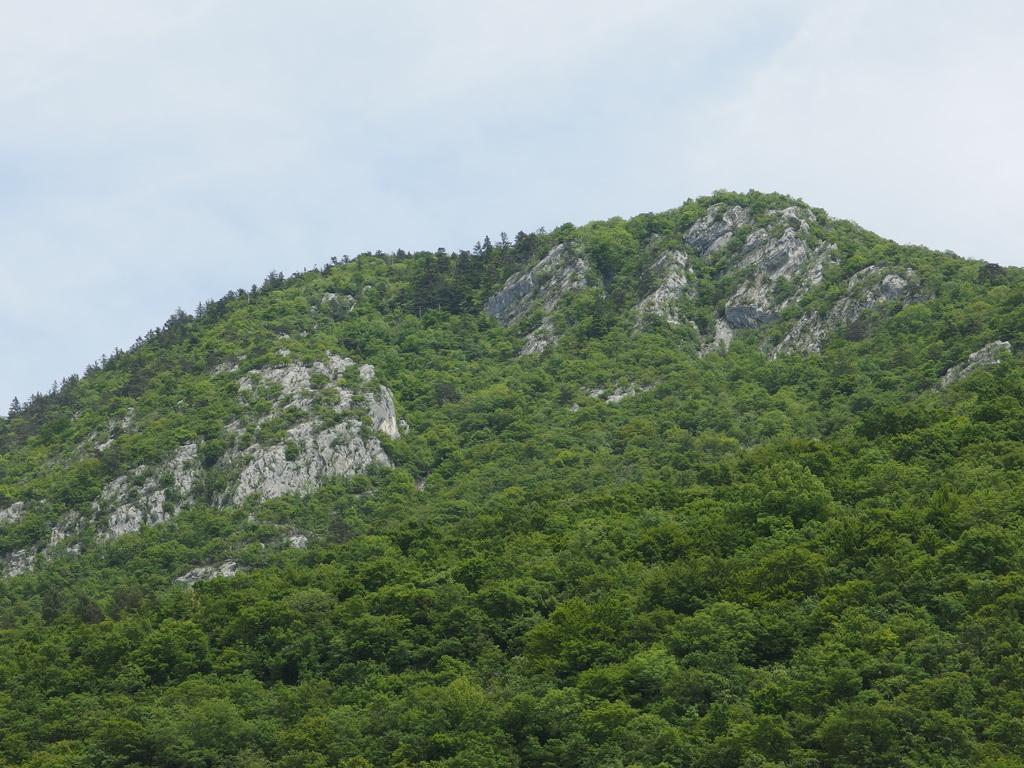Where was the picture taken? The picture was clicked outside. What can be seen in the center of the image? There are green leaves and rocks in the center of the image. What is visible in the background of the image? The sky is visible in the background of the image. What time of day is it in the image? The time of day cannot be determined from the image, as there are no specific indicators of time. 